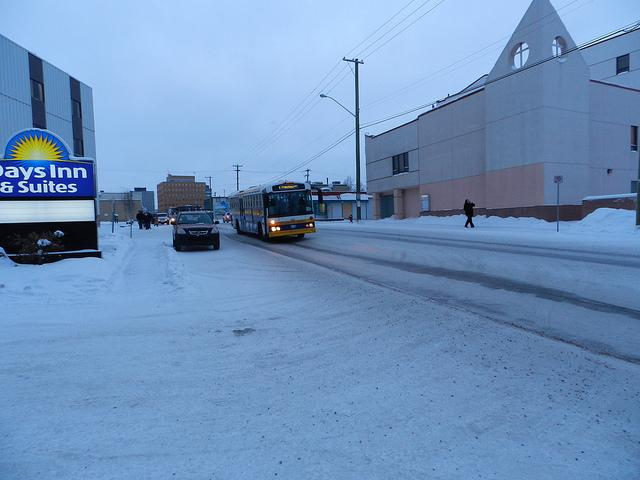What kind of building is the one with the sign on the left?

Choices:
A) hotel
B) restaurant
C) pub
D) library hotel 